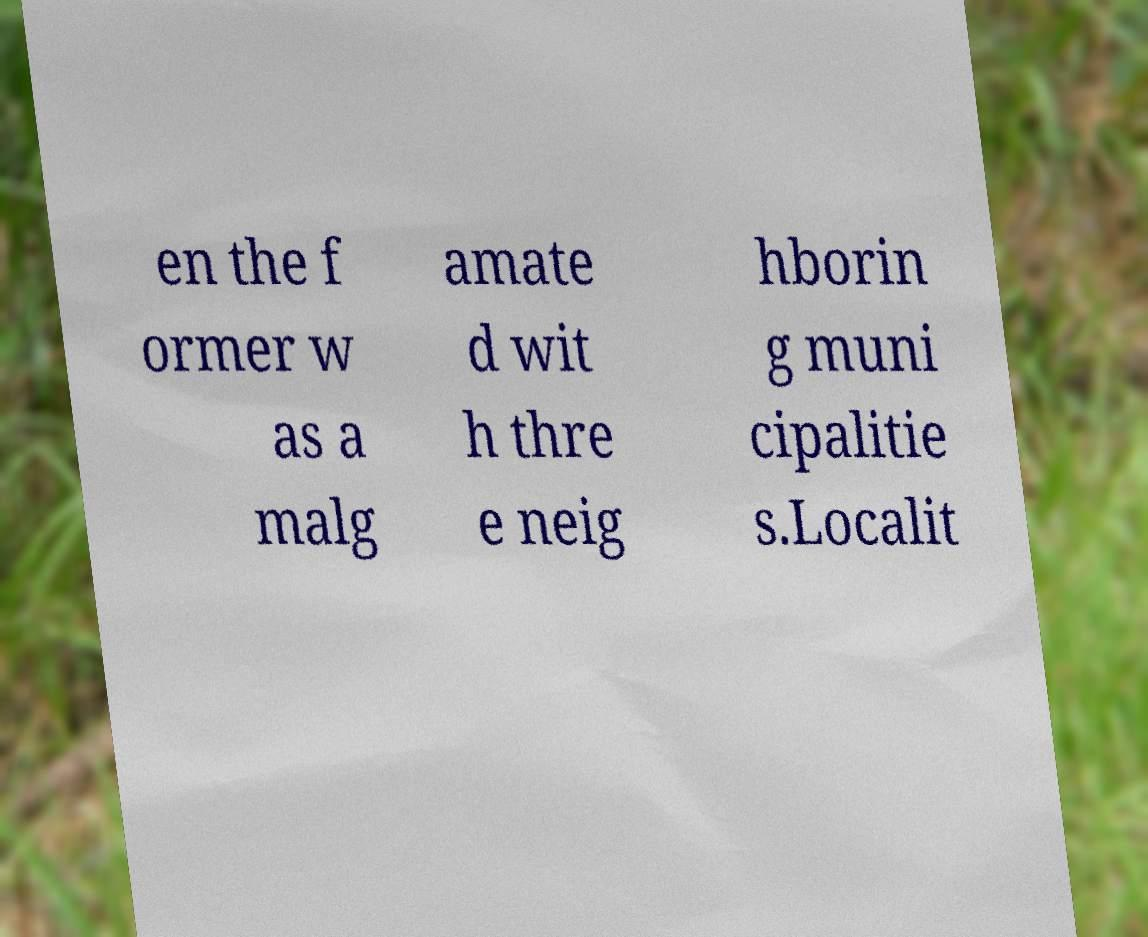For documentation purposes, I need the text within this image transcribed. Could you provide that? en the f ormer w as a malg amate d wit h thre e neig hborin g muni cipalitie s.Localit 